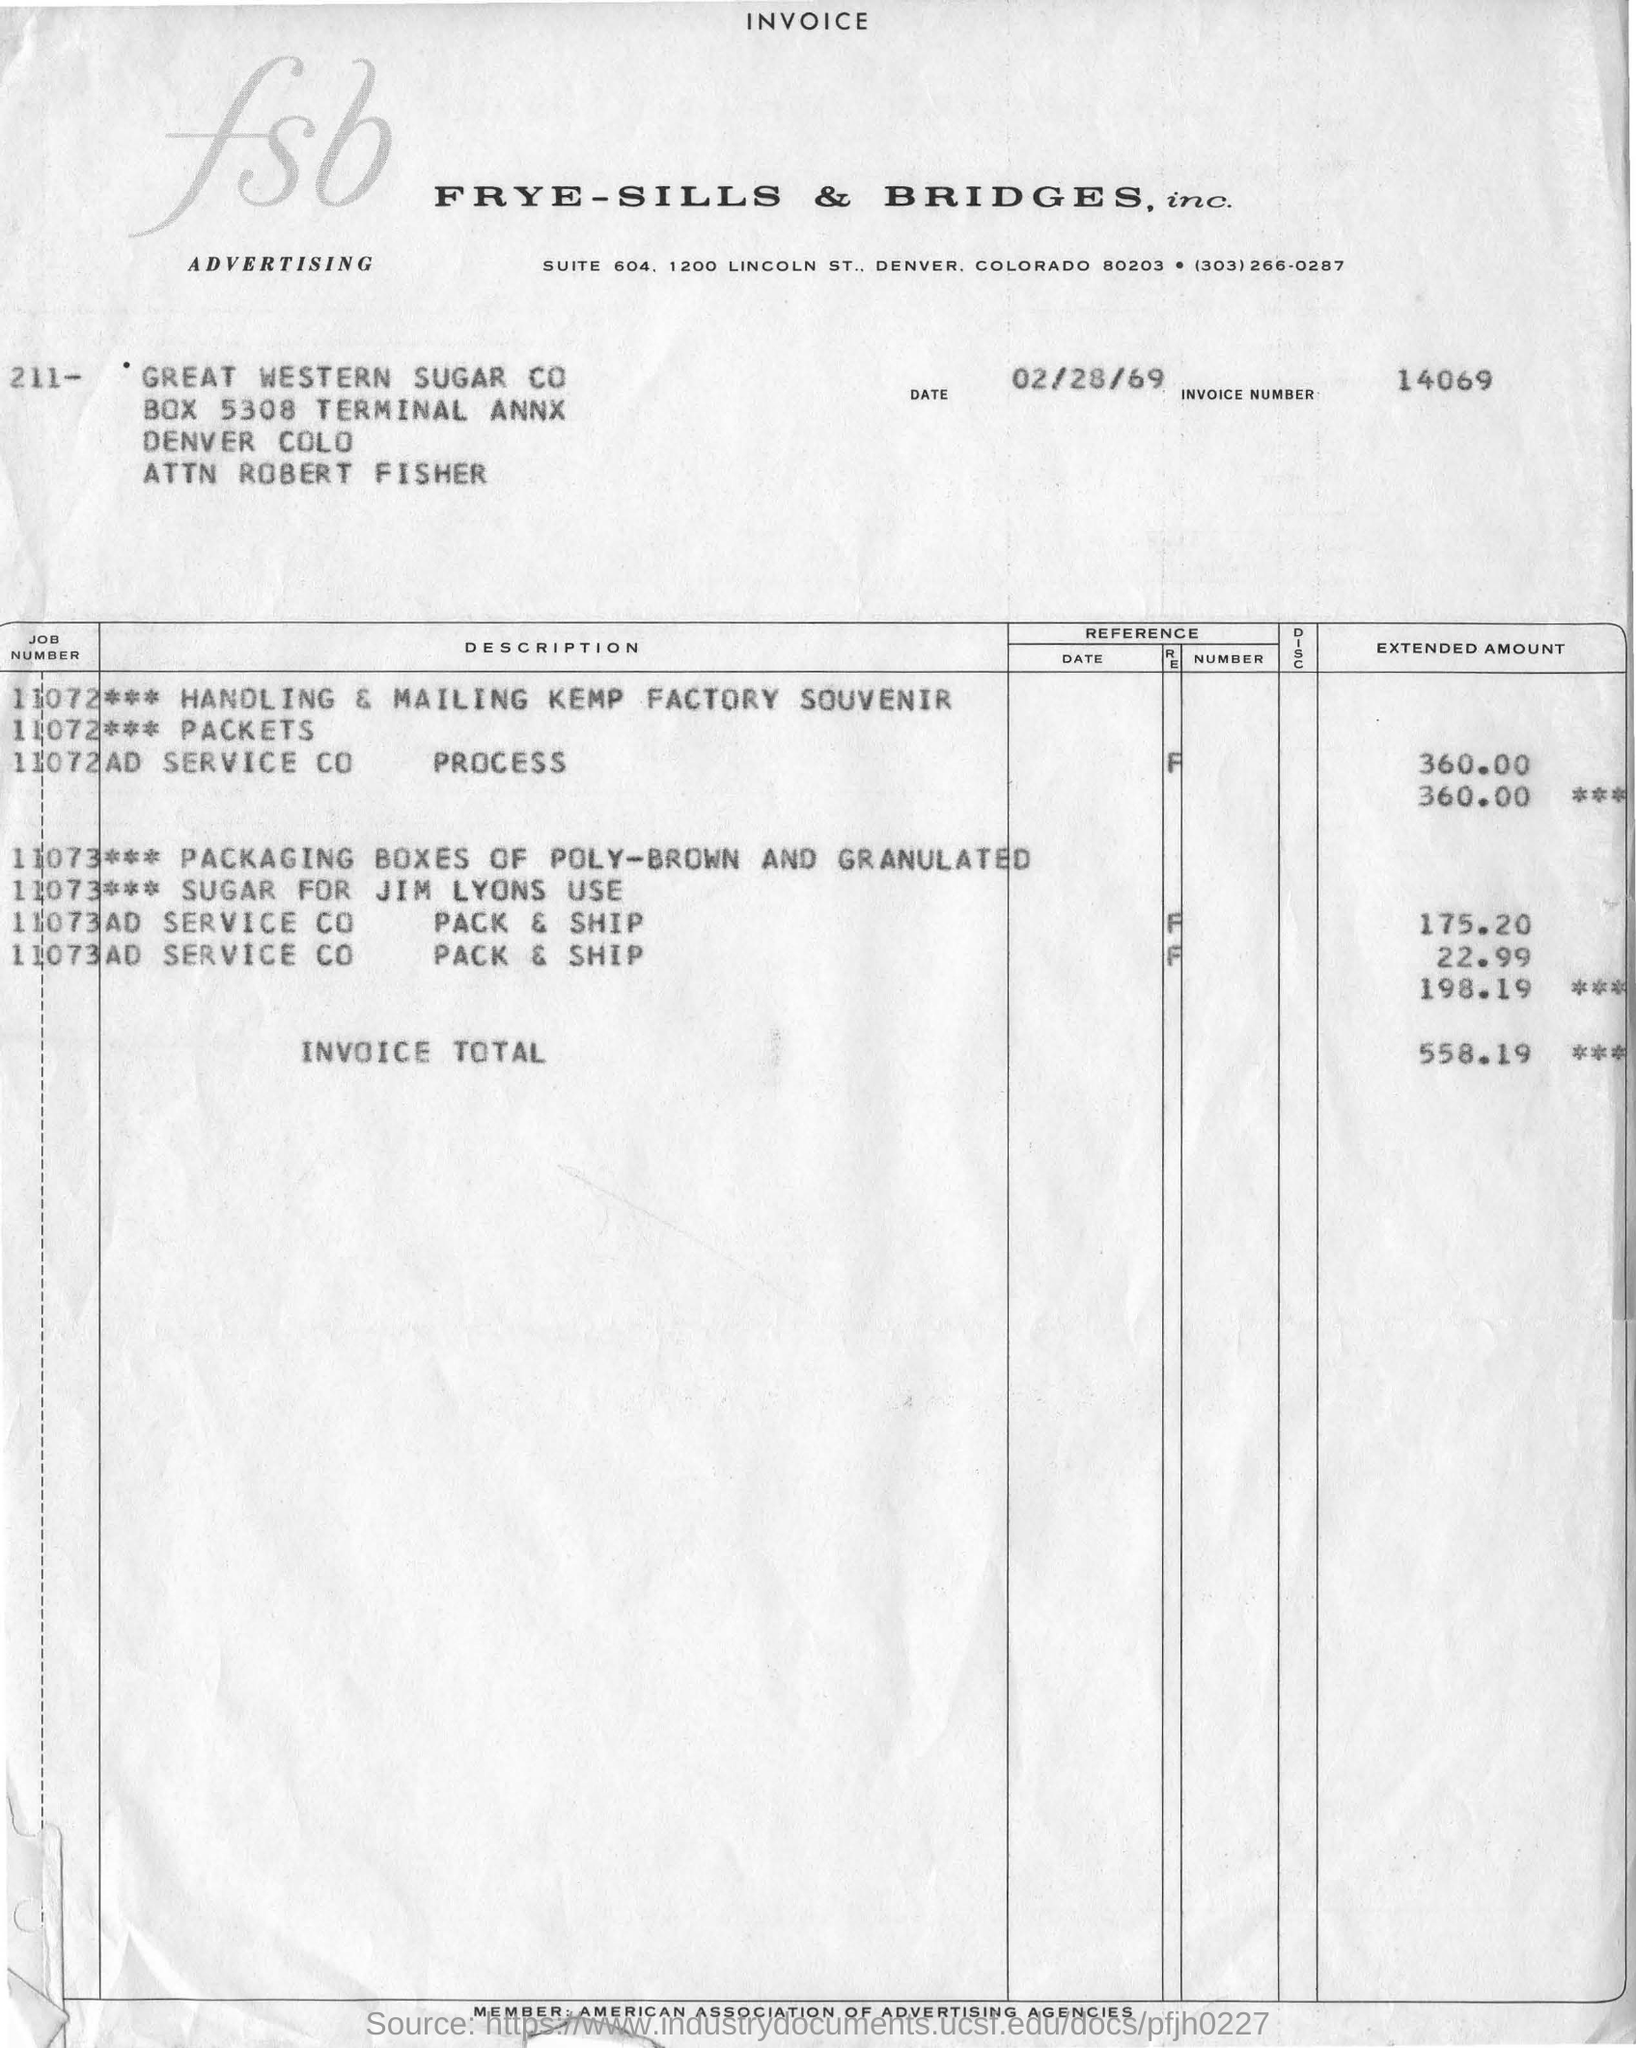Which organisation's invoice is this?
Offer a very short reply. FRYE-SILLS & BRIDGES, inc. What is the invoice number?
Your answer should be compact. 14069. What is the invoice total?
Make the answer very short. 558.19. 